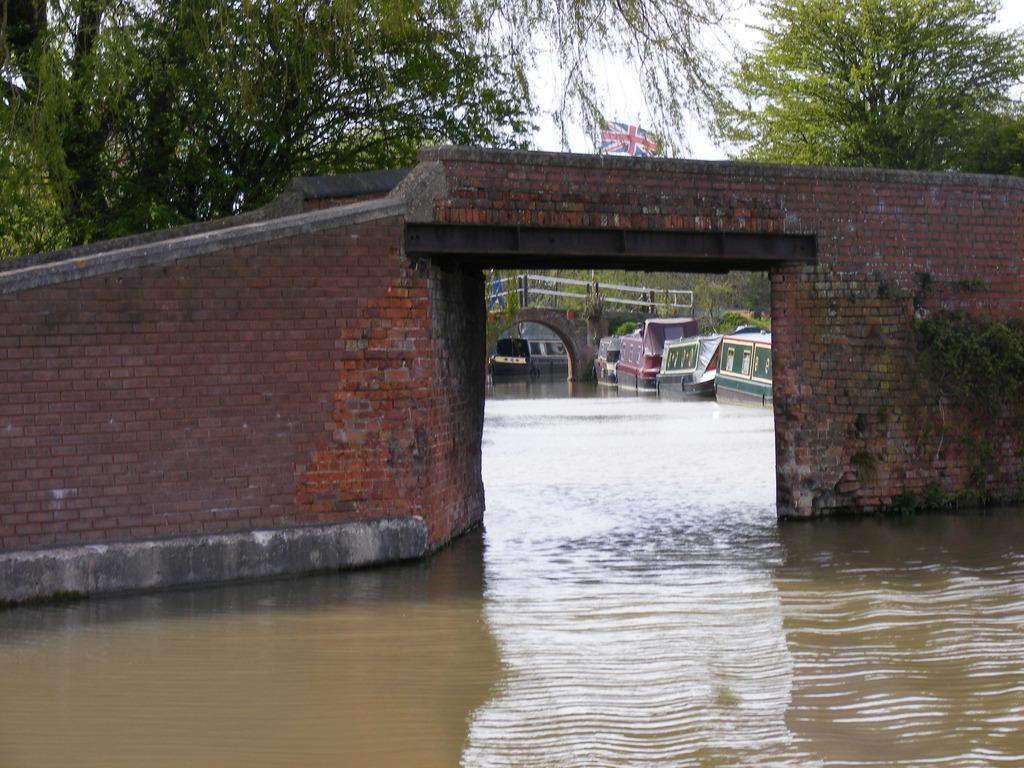What is on the water in the image? There are boats on the water in the image. What structure can be seen in the image? There is a bridge in the image. What type of architectural feature is present in the image? There is a wall in the image. What type of vegetation is visible in the image? There are trees in the image. Who or what is present in the image? There are people in the image. What symbol can be seen in the image? There is a flag in the image. What part of the natural environment is visible in the image? The sky is visible in the background of the image. Where is the truck parked in the image? There is no truck present in the image. What type of seat is visible in the image? There is no seat present in the image. 